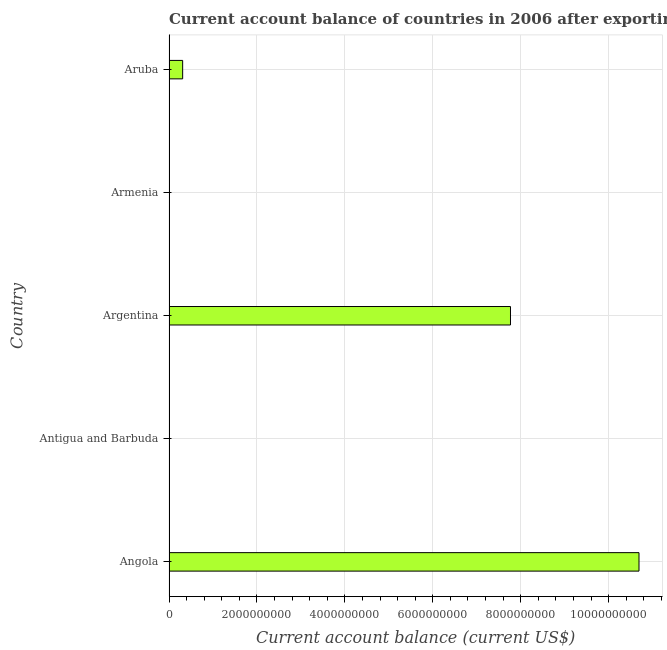Does the graph contain any zero values?
Provide a short and direct response. Yes. What is the title of the graph?
Your response must be concise. Current account balance of countries in 2006 after exporting goods and services. What is the label or title of the X-axis?
Offer a very short reply. Current account balance (current US$). What is the label or title of the Y-axis?
Offer a terse response. Country. Across all countries, what is the maximum current account balance?
Ensure brevity in your answer.  1.07e+1. In which country was the current account balance maximum?
Make the answer very short. Angola. What is the sum of the current account balance?
Your response must be concise. 1.88e+1. What is the difference between the current account balance in Angola and Aruba?
Ensure brevity in your answer.  1.04e+1. What is the average current account balance per country?
Provide a short and direct response. 3.75e+09. What is the median current account balance?
Ensure brevity in your answer.  3.11e+08. What is the difference between the highest and the second highest current account balance?
Offer a terse response. 2.92e+09. What is the difference between the highest and the lowest current account balance?
Your answer should be compact. 1.07e+1. In how many countries, is the current account balance greater than the average current account balance taken over all countries?
Give a very brief answer. 2. How many bars are there?
Offer a very short reply. 3. How many countries are there in the graph?
Your answer should be very brief. 5. What is the difference between two consecutive major ticks on the X-axis?
Give a very brief answer. 2.00e+09. Are the values on the major ticks of X-axis written in scientific E-notation?
Offer a terse response. No. What is the Current account balance (current US$) of Angola?
Give a very brief answer. 1.07e+1. What is the Current account balance (current US$) in Antigua and Barbuda?
Offer a very short reply. 0. What is the Current account balance (current US$) in Argentina?
Offer a very short reply. 7.77e+09. What is the Current account balance (current US$) of Armenia?
Your answer should be very brief. 0. What is the Current account balance (current US$) of Aruba?
Make the answer very short. 3.11e+08. What is the difference between the Current account balance (current US$) in Angola and Argentina?
Keep it short and to the point. 2.92e+09. What is the difference between the Current account balance (current US$) in Angola and Aruba?
Provide a succinct answer. 1.04e+1. What is the difference between the Current account balance (current US$) in Argentina and Aruba?
Your answer should be very brief. 7.46e+09. What is the ratio of the Current account balance (current US$) in Angola to that in Argentina?
Offer a terse response. 1.38. What is the ratio of the Current account balance (current US$) in Angola to that in Aruba?
Give a very brief answer. 34.42. What is the ratio of the Current account balance (current US$) in Argentina to that in Aruba?
Make the answer very short. 25.01. 